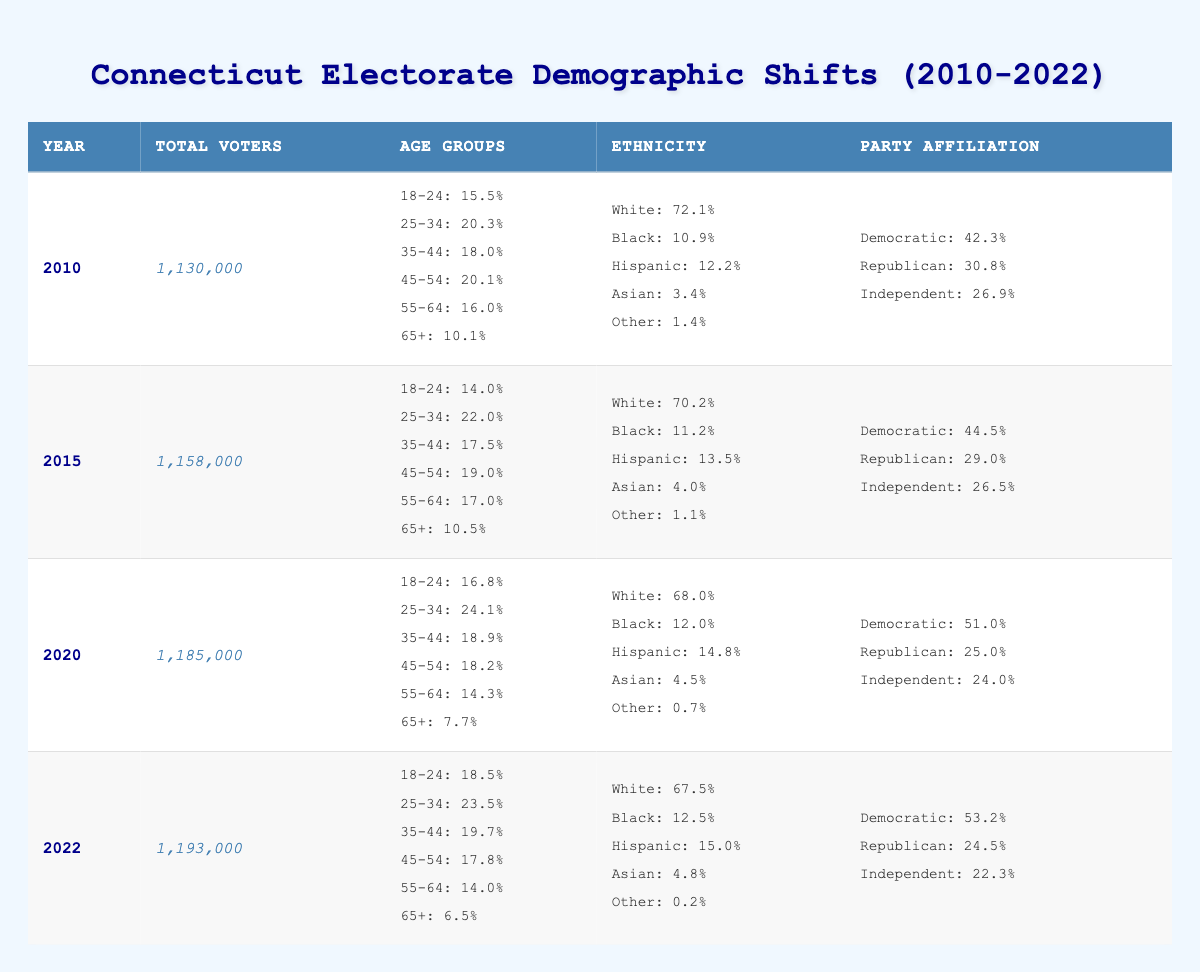What was the total number of voters in Connecticut in 2020? Looking at the table, under the year 2020, the "Total Voters" column shows 1,185,000.
Answer: 1,185,000 What percentage of voters were aged 65 and older in 2015? In the row for 2015, the "Age Groups" column indicates that 10.5% of voters were aged 65 and older.
Answer: 10.5% Did the percentage of Hispanic voters increase from 2010 to 2022? In 2010, Hispanic voters were 12.2% and in 2022 they were 15.0%. Since 15.0% is greater than 12.2%, the percentage did increase.
Answer: Yes What was the difference in the percentage of Democratic voters between 2010 and 2020? In 2010, 42.3% of voters were Democratic. In 2020, the percentage rose to 51.0%. The difference is 51.0% - 42.3% = 8.7%.
Answer: 8.7% What demographic age group had the highest percentage of voters in 2010? Referring to the "Age Groups" for 2010, the 45-54 age group with 20.1% had the highest percentage compared to other age groups.
Answer: 45-54 What was the average percentage of Black voters over the four years from 2010 to 2022? The percentages for Black voters over these years are 10.9, 11.2, 12.0, and 12.5. To find the average, sum these values (10.9 + 11.2 + 12.0 + 12.5 = 46.6) and divide by the 4 data points (46.6 / 4 = 11.65).
Answer: 11.65 Was the percentage of Independent voters lower in 2022 than in 2010? In 2010, Independent voters made up 26.9% of the electorate, whereas in 2022 it dropped to 22.3%. Therefore, the percentage of Independent voters was lower in 2022.
Answer: Yes What trend can be observed in the age group 18-24 from 2010 to 2022? The percentage of voters aged 18-24 decreased from 15.5% in 2010 to 18.5% in 2022, indicating a rising trend. It's essential to see the numbers are increasing over the years from 2010 to 2022.
Answer: Rising trend How did the percentage of Asian voters change from 2010 to 2022? In 2010, 3.4% of voters were Asian, and this increased to 4.8% in 2022. Therefore, the percentage of Asian voters increased over this period.
Answer: Increased What is the total number of voters in 2015 and 2020 combined? In 2015, there were 1,158,000 voters and in 2020, there were 1,185,000 voters. Adding these gives 1,158,000 + 1,185,000 = 2,343,000.
Answer: 2,343,000 